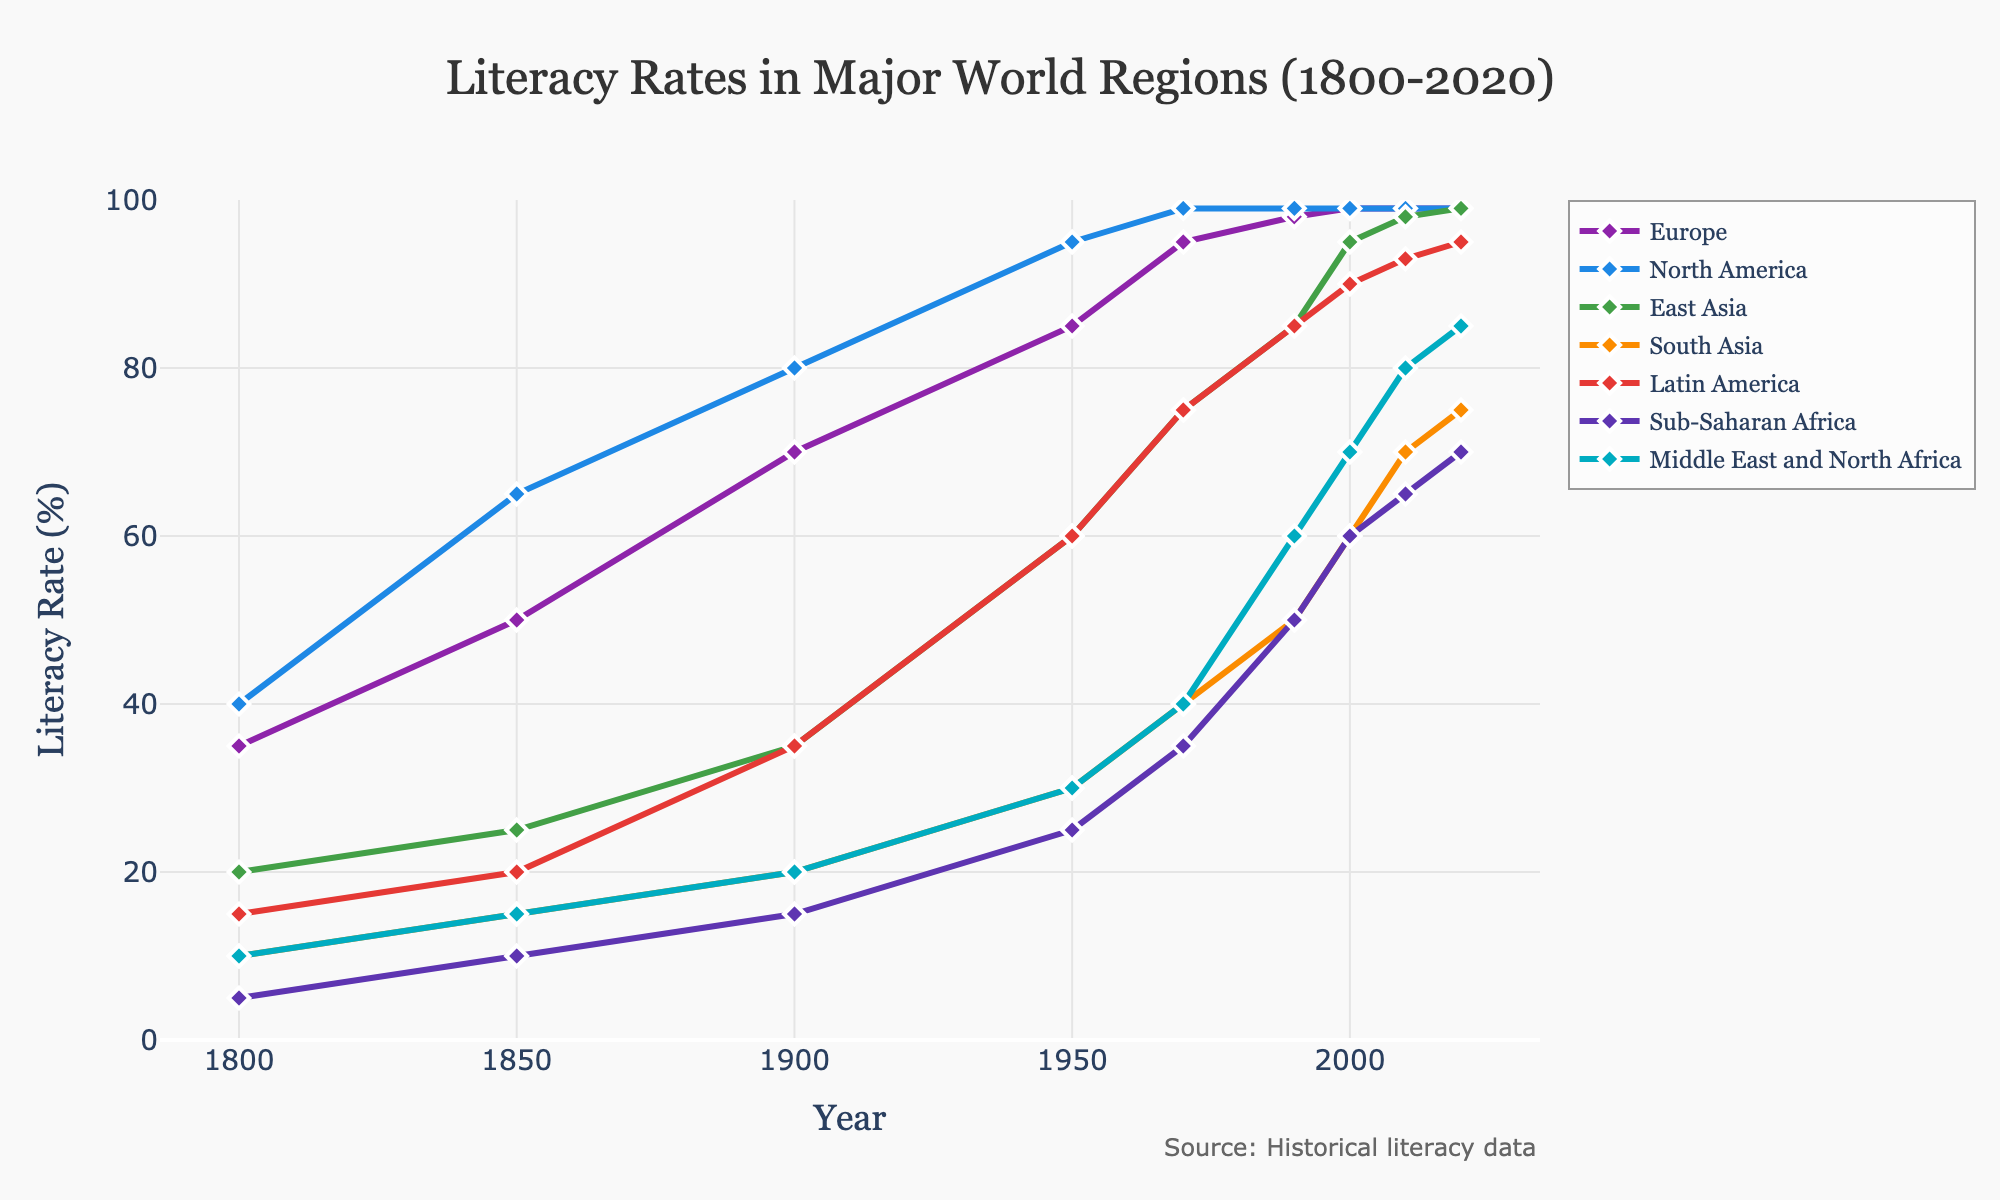Which region had the lowest literacy rate in 1800? The figure shows that Sub-Saharan Africa had the lowest literacy rate at 5% in 1800 compared to other regions.
Answer: Sub-Saharan Africa What was the literacy rate difference between North America and South Asia in 1950? In 1950, the literacy rate in North America was 95%, and in South Asia, it was 30%. The difference is calculated by subtracting South Asia's rate from North America's rate: 95% - 30% = 65%.
Answer: 65% Which regions had nearly the same literacy rate by 2020, and what was that rate? The figure shows that Europe, North America, and East Asia had a literacy rate of 99% by 2020, which is nearly the same.
Answer: Europe, North America, East Asia; 99% How did the literacy rate in East Asia change from 1800 to 2020? In East Asia, the literacy rate increased from 20% in 1800 to 99% in 2020. To calculate the change: 99% - 20% = 79%.
Answer: Increased by 79% Compare the literacy rate trends in Latin America and Sub-Saharan Africa from 1900 to 2020. In 1900, Latin America had a literacy rate of 35% while Sub-Saharan Africa had 15%. By 2020, Latin America's literacy rate increased to 95% and Sub-Saharan Africa's to 70%. Both regions showed significant improvement, but Latin America consistently had higher rates throughout the period.
Answer: Latin America consistently higher; both improved What is the average literacy rate for Europe over the years 1850, 1900, and 1950? To find the average, add the literacy rates for Europe in these years and divide by 3: (50% (1850) + 70% (1900) + 85% (1950)) / 3 = 205% / 3 = 68.33%.
Answer: 68.33% Which region showed the most rapid increase in literacy rates between 1950 and 2020? Compare the rate of increase: East Asia increased from 60% to 99%, a 39% rise. Other regions had smaller increases; therefore, East Asia shows the most rapid increase.
Answer: East Asia Across all regions, which decade shows the most significant overall increase in literacy rates? Compare the increases across the decades: The most significant increase appears in the period between 1900 and 1950 for many regions where literacy rates jumped considerably, especially in East Asia, Latin America, and North America.
Answer: 1900-1950 In 2020, how did the literacy rate of the Middle East and North Africa compare to South Asia? In 2020, the Middle East and North Africa had a literacy rate of 85%, while South Asia had 75%. The Middle East and North Africa's rate is higher by 10%.
Answer: Middle East and North Africa was higher by 10% What is the difference between the highest and lowest literacy rates in 1850? In 1850, North America had the highest rate at 65%, and Sub-Saharan Africa had the lowest at 10%. The difference is 65% - 10% = 55%.
Answer: 55% 